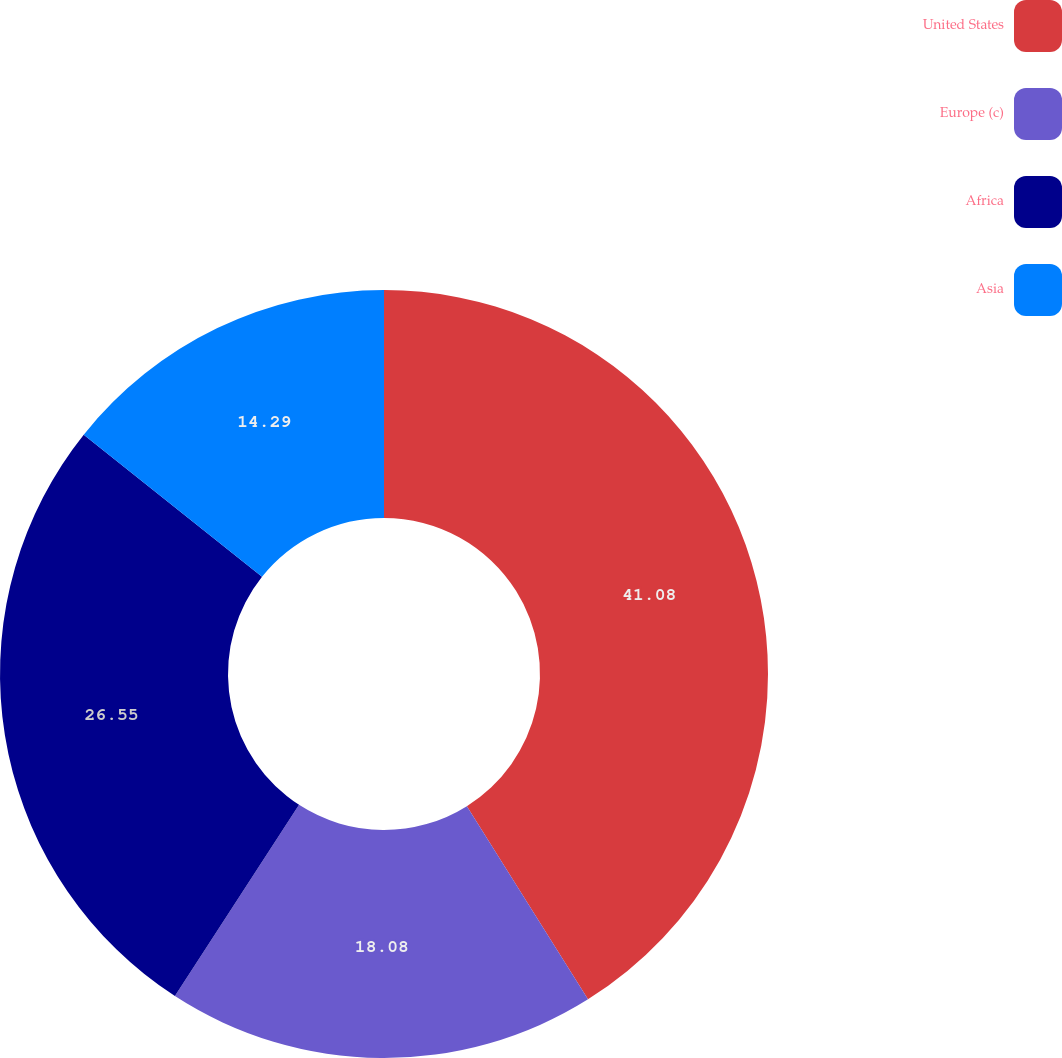Convert chart. <chart><loc_0><loc_0><loc_500><loc_500><pie_chart><fcel>United States<fcel>Europe (c)<fcel>Africa<fcel>Asia<nl><fcel>41.09%<fcel>18.08%<fcel>26.55%<fcel>14.29%<nl></chart> 